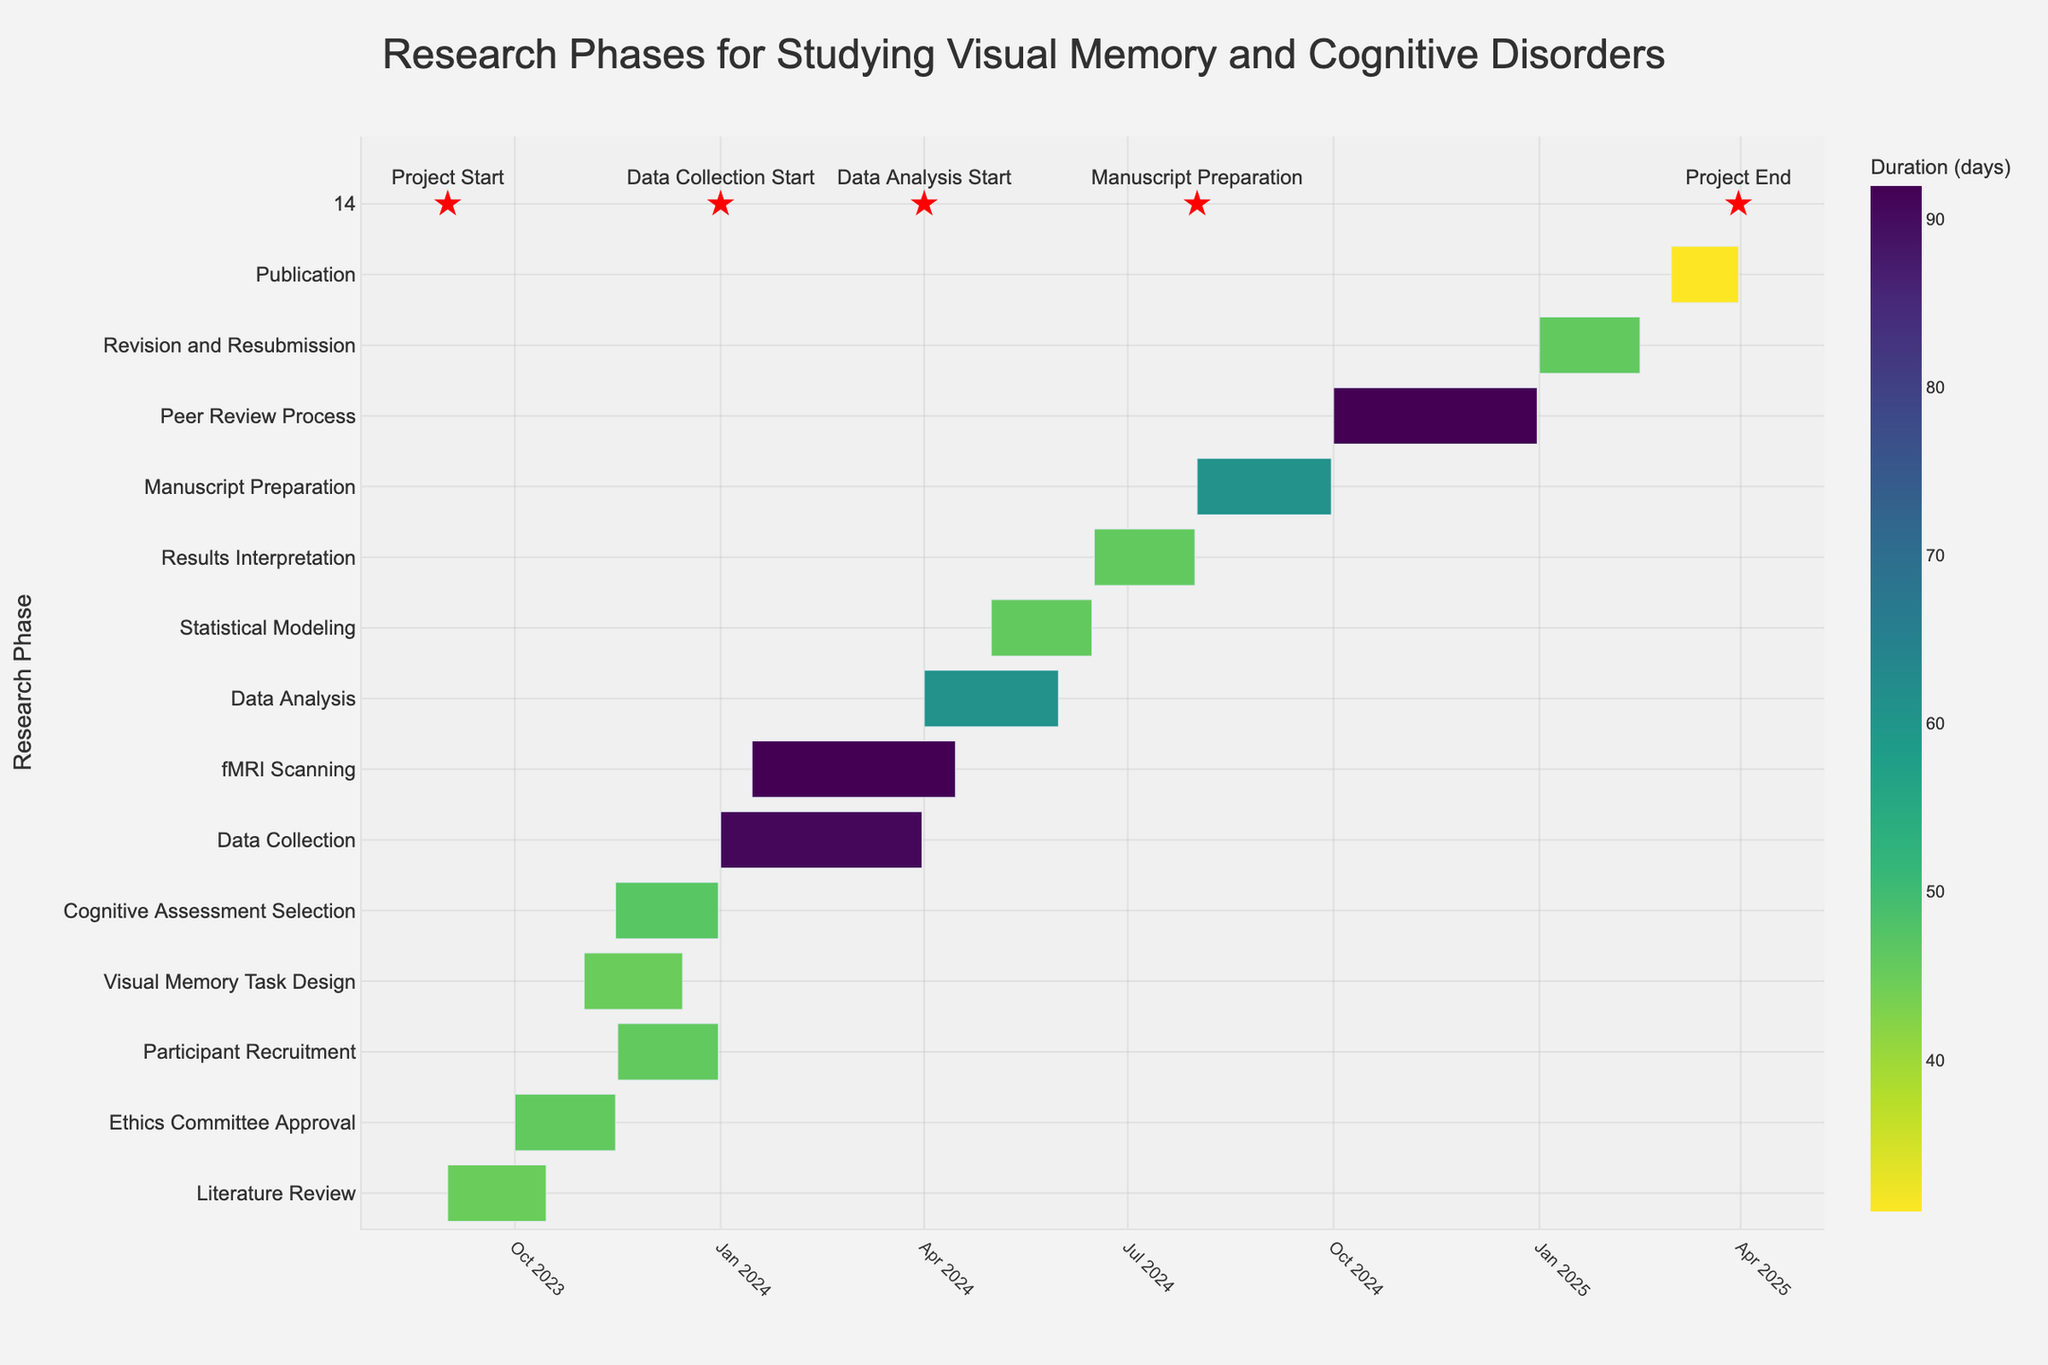What is the duration of the "Data Collection" phase? The "Data Collection" phase is labeled with its duration as 91 days on the Gantt chart.
Answer: 91 days Which phase occurs directly after "Ethics Committee Approval"? Following the timeline visually from "Ethics Committee Approval," the next phase is "Participant Recruitment," which starts on November 16, 2023, the day after "Ethics Committee Approval" ends.
Answer: "Participant Recruitment" Between which months does the "fMRI Scanning" phase take place? The start and end dates for the "fMRI Scanning" phase are indicated on the Gantt chart as January 15, 2024, and April 15, 2024, respectively.
Answer: January to April 2024 How many phases have a duration of more than 60 days? To answer this, count the phases with a duration over 60 days: "Data Collection" (91), "fMRI Scanning" (92), "Peer Review Process" (92), and "Manuscript Preparation" (61), totaling 4 phases.
Answer: 4 phases When does "Manuscript Preparation" start in relation to "Data Analysis"? The start date of "Manuscript Preparation" is August 1, 2024, while "Data Analysis" starts on April 1, 2024. "Manuscript Preparation" starts exactly 4 months after "Data Analysis" begins.
Answer: 4 months after Which two phases overlap in December 2023? Look for phases that span December 2023. "Participant Recruitment," "Visual Memory Task Design," and "Cognitive Assessment Selection" all overlap during this month.
Answer: "Participant Recruitment", "Visual Memory Task Design", "Cognitive Assessment Selection" What is the total duration from the "Project Start" to the completion of the "Publication" phase? The project starts on September 1, 2023, and the "Publication" phase ends on March 31, 2025. The total duration can be calculated as the difference between these dates, resulting in 943 days.
Answer: 943 days Which phase has the shortest duration, and how long is it? Reviewing the Gantt chart, "Publication" has the shortest duration of 31 days.
Answer: "Publication" (31 days) How long after "Data Collection" does "Data Analysis" begin? "Data Collection" ends on March 31, 2024, and "Data Analysis" starts the following day, April 1, 2024. Therefore, "Data Analysis" begins the day after "Data Collection" ends.
Answer: 1 day 